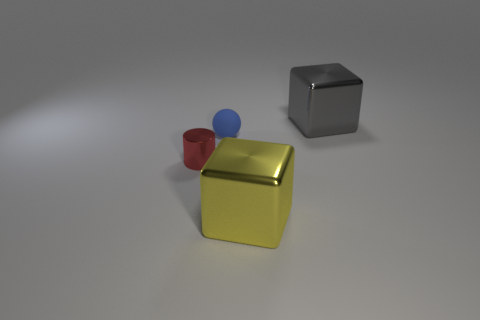Is there any other thing that is made of the same material as the blue sphere?
Your answer should be compact. No. Are there fewer gray cubes that are to the left of the gray shiny object than big metallic blocks behind the red object?
Give a very brief answer. Yes. There is another metal object that is the same shape as the big gray metallic object; what is its size?
Keep it short and to the point. Large. How many objects are shiny blocks that are on the right side of the yellow metallic cube or shiny things in front of the big gray metallic block?
Your answer should be very brief. 3. Do the blue thing and the yellow shiny block have the same size?
Keep it short and to the point. No. Is the number of small metallic objects greater than the number of green rubber cubes?
Your response must be concise. Yes. What number of things are big gray things or tiny metal objects?
Your answer should be compact. 2. Does the tiny thing in front of the rubber thing have the same shape as the large gray object?
Make the answer very short. No. The cube that is behind the metallic cube that is in front of the ball is what color?
Give a very brief answer. Gray. Is the number of large gray metal cubes less than the number of small gray cubes?
Keep it short and to the point. No. 